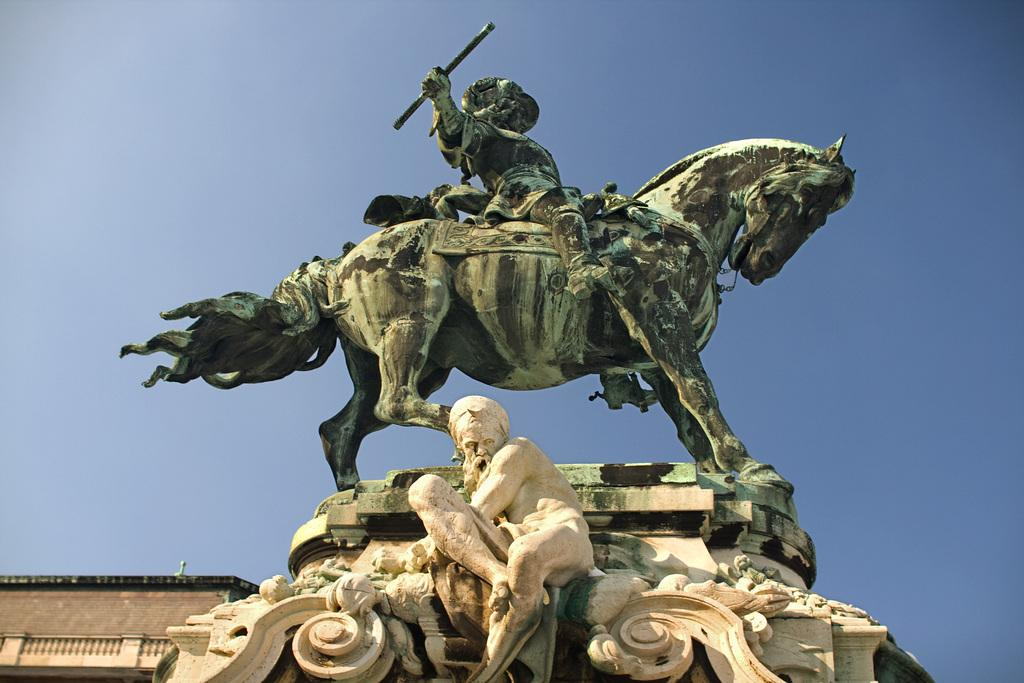What is depicted in the image involving a person and a horse? There are statues of a person sitting on a horse and holding a rod in the image. What type of structure can be seen in the image? There is a building in the image. What can be seen in the background of the image? The sky is visible in the background of the image. What type of marble is the pet sitting on in the image? There is no pet present in the image, so it is not possible to determine what type of marble it might be sitting on. 